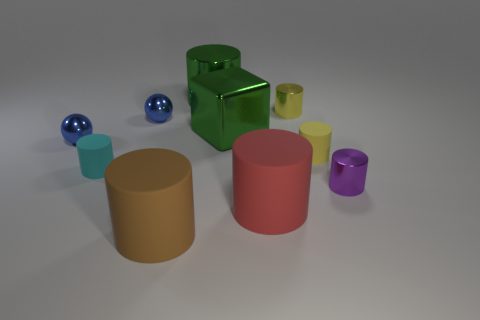Does the cube have the same color as the big metal cylinder?
Make the answer very short. Yes. What number of other things are the same color as the cube?
Offer a terse response. 1. There is a small yellow thing that is behind the block; is its shape the same as the large brown matte object to the left of the small yellow rubber cylinder?
Offer a terse response. Yes. How many balls are big brown matte things or green objects?
Provide a succinct answer. 0. Is the number of purple metal things in front of the purple thing less than the number of large yellow metallic cubes?
Provide a short and direct response. No. How many other things are the same material as the purple cylinder?
Give a very brief answer. 5. Does the yellow shiny object have the same size as the cyan matte cylinder?
Provide a short and direct response. Yes. What number of things are either metal cylinders that are to the right of the red cylinder or yellow cylinders?
Provide a short and direct response. 3. What material is the yellow object in front of the tiny metallic cylinder that is to the left of the purple shiny thing?
Provide a short and direct response. Rubber. Is there a cyan thing that has the same shape as the yellow matte object?
Give a very brief answer. Yes. 